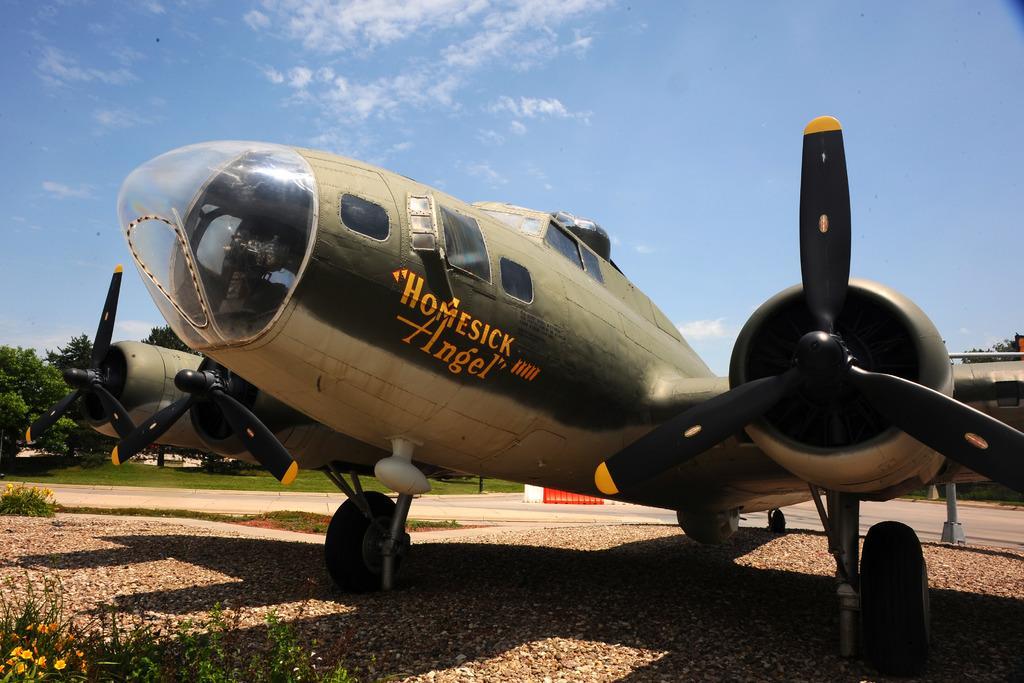In one or two sentences, can you explain what this image depicts? In this image I can see an aircraft which is in green and white color, at left I can see trees in green color, at top sky is in white and blue color. 